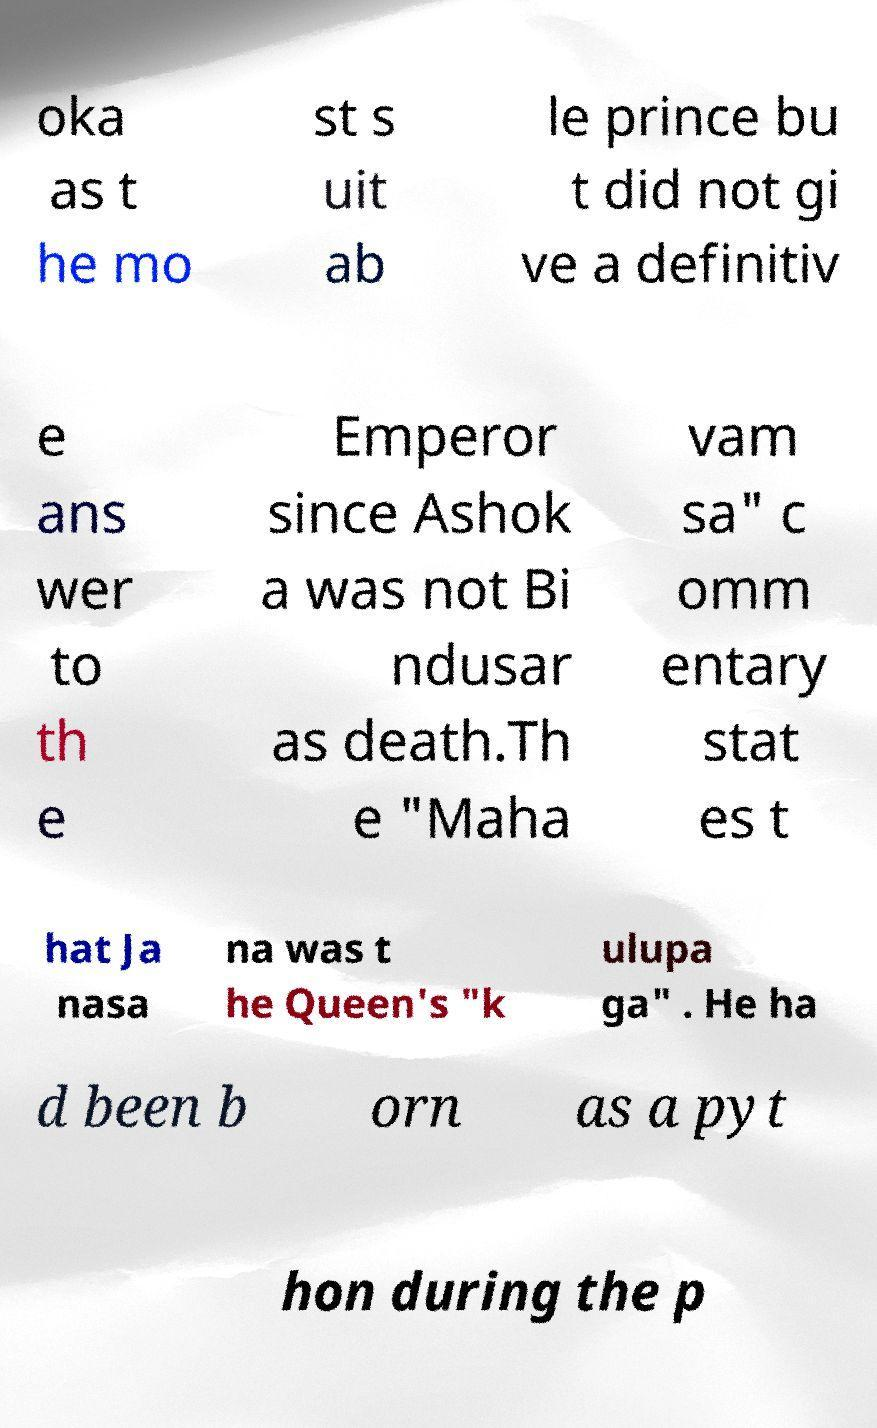For documentation purposes, I need the text within this image transcribed. Could you provide that? oka as t he mo st s uit ab le prince bu t did not gi ve a definitiv e ans wer to th e Emperor since Ashok a was not Bi ndusar as death.Th e "Maha vam sa" c omm entary stat es t hat Ja nasa na was t he Queen's "k ulupa ga" . He ha d been b orn as a pyt hon during the p 